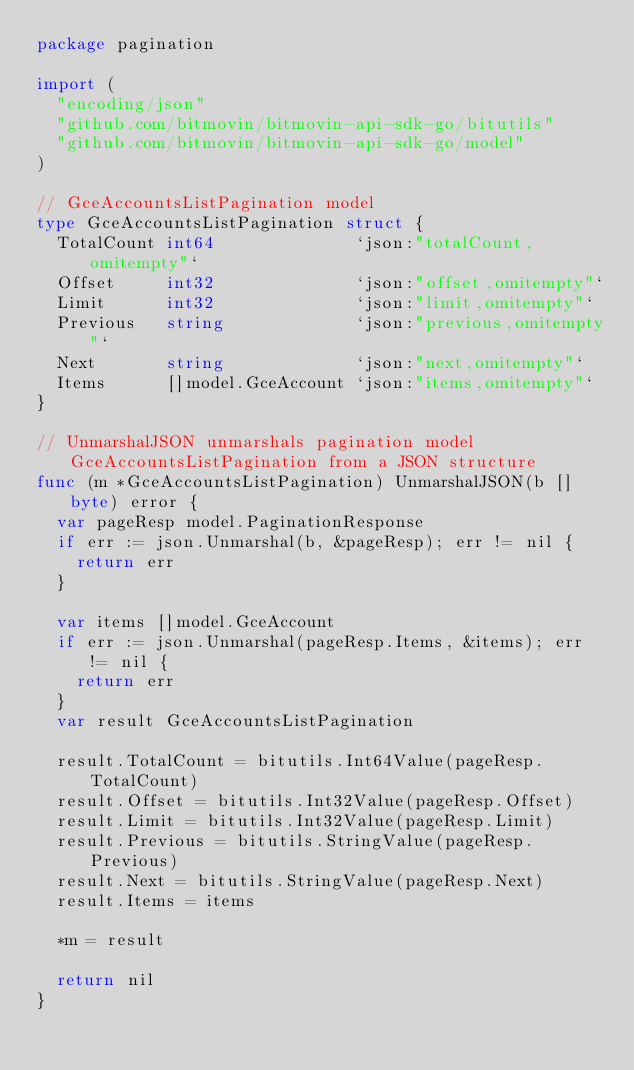<code> <loc_0><loc_0><loc_500><loc_500><_Go_>package pagination

import (
	"encoding/json"
	"github.com/bitmovin/bitmovin-api-sdk-go/bitutils"
	"github.com/bitmovin/bitmovin-api-sdk-go/model"
)

// GceAccountsListPagination model
type GceAccountsListPagination struct {
	TotalCount int64              `json:"totalCount,omitempty"`
	Offset     int32              `json:"offset,omitempty"`
	Limit      int32              `json:"limit,omitempty"`
	Previous   string             `json:"previous,omitempty"`
	Next       string             `json:"next,omitempty"`
	Items      []model.GceAccount `json:"items,omitempty"`
}

// UnmarshalJSON unmarshals pagination model GceAccountsListPagination from a JSON structure
func (m *GceAccountsListPagination) UnmarshalJSON(b []byte) error {
	var pageResp model.PaginationResponse
	if err := json.Unmarshal(b, &pageResp); err != nil {
		return err
	}

	var items []model.GceAccount
	if err := json.Unmarshal(pageResp.Items, &items); err != nil {
		return err
	}
	var result GceAccountsListPagination

	result.TotalCount = bitutils.Int64Value(pageResp.TotalCount)
	result.Offset = bitutils.Int32Value(pageResp.Offset)
	result.Limit = bitutils.Int32Value(pageResp.Limit)
	result.Previous = bitutils.StringValue(pageResp.Previous)
	result.Next = bitutils.StringValue(pageResp.Next)
	result.Items = items

	*m = result

	return nil
}
</code> 